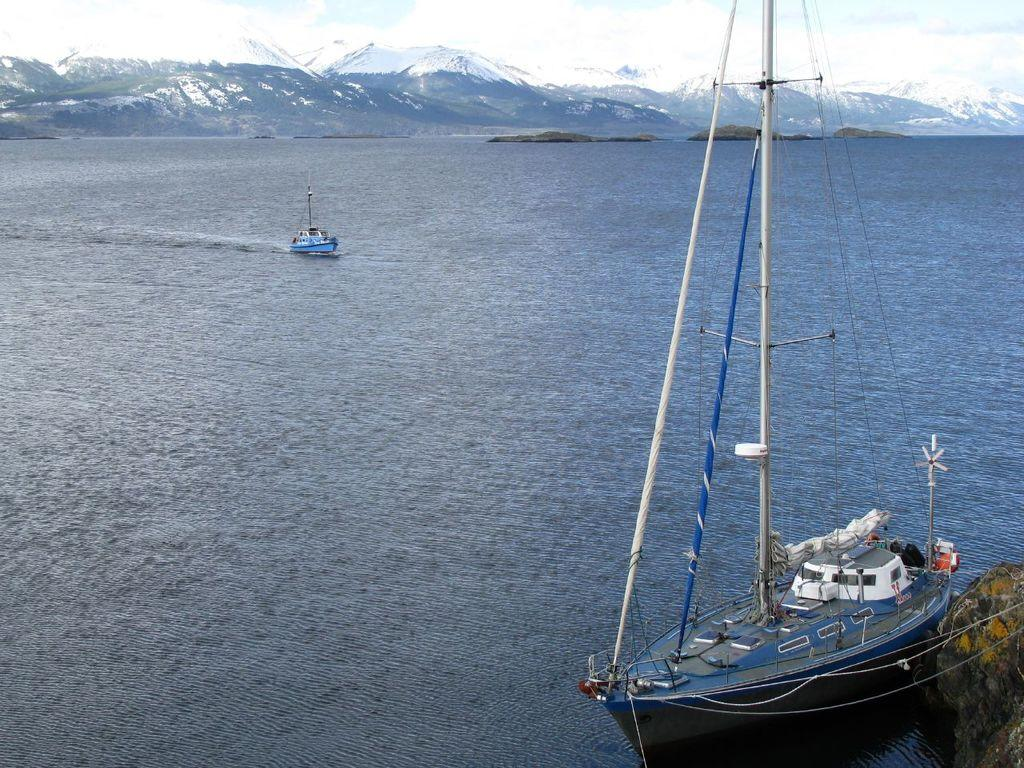What is on the water in the image? There are boats on the water in the image. What can be seen in the distance in the image? There are hills visible in the background of the image. What else is present in the background of the image? Clouds are present in the background of the image. Can you see any vests being worn by the boats in the image? There are no people or vests visible in the image; it only features boats on the water. How many ears can be counted on the boats in the image? There are no ears present in the image; it only features boats on the water. 